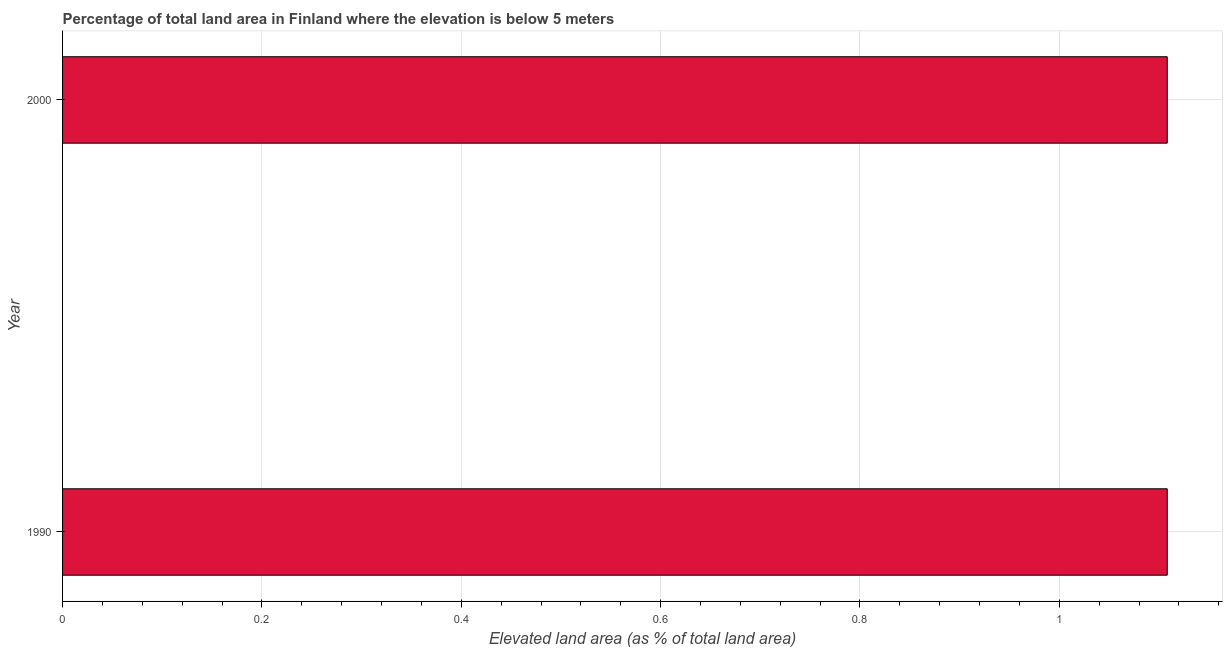What is the title of the graph?
Provide a short and direct response. Percentage of total land area in Finland where the elevation is below 5 meters. What is the label or title of the X-axis?
Make the answer very short. Elevated land area (as % of total land area). What is the total elevated land area in 1990?
Offer a very short reply. 1.11. Across all years, what is the maximum total elevated land area?
Offer a very short reply. 1.11. Across all years, what is the minimum total elevated land area?
Your answer should be compact. 1.11. In which year was the total elevated land area maximum?
Provide a succinct answer. 1990. In which year was the total elevated land area minimum?
Offer a terse response. 1990. What is the sum of the total elevated land area?
Provide a short and direct response. 2.22. What is the difference between the total elevated land area in 1990 and 2000?
Your response must be concise. 0. What is the average total elevated land area per year?
Keep it short and to the point. 1.11. What is the median total elevated land area?
Provide a succinct answer. 1.11. Do a majority of the years between 1990 and 2000 (inclusive) have total elevated land area greater than 0.6 %?
Provide a succinct answer. Yes. Is the total elevated land area in 1990 less than that in 2000?
Give a very brief answer. No. In how many years, is the total elevated land area greater than the average total elevated land area taken over all years?
Offer a terse response. 0. How many bars are there?
Offer a very short reply. 2. What is the difference between two consecutive major ticks on the X-axis?
Offer a very short reply. 0.2. Are the values on the major ticks of X-axis written in scientific E-notation?
Provide a succinct answer. No. What is the Elevated land area (as % of total land area) in 1990?
Keep it short and to the point. 1.11. What is the Elevated land area (as % of total land area) of 2000?
Provide a succinct answer. 1.11. 